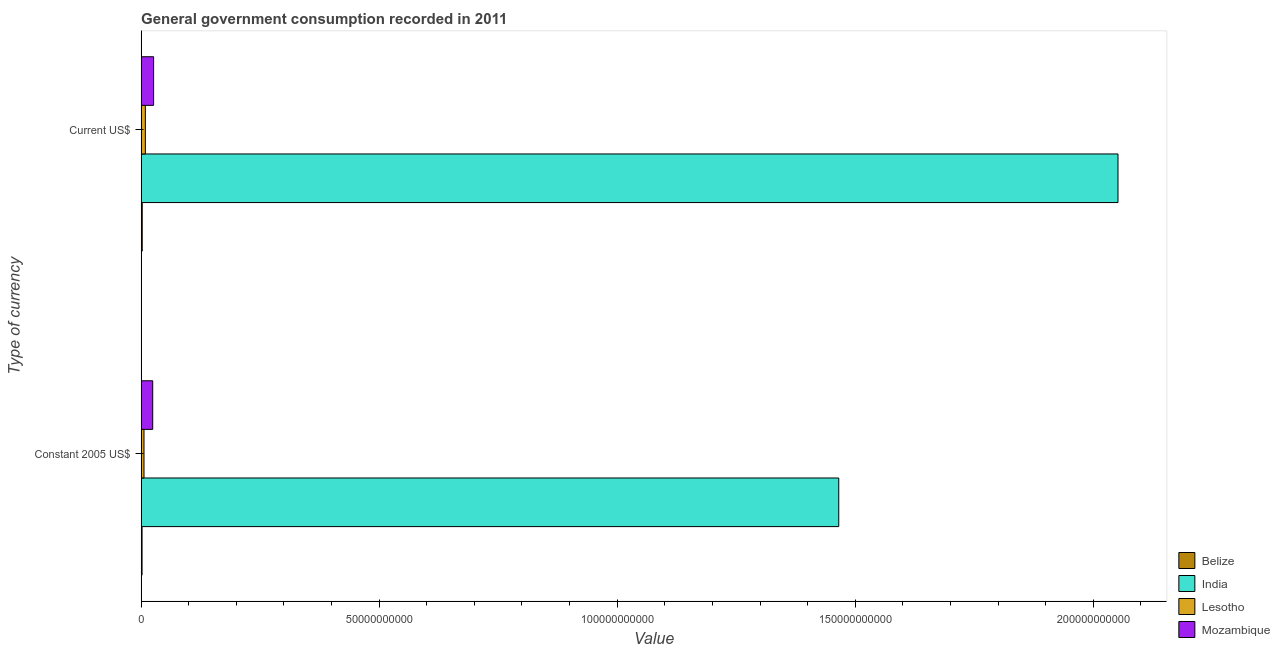How many groups of bars are there?
Provide a short and direct response. 2. Are the number of bars on each tick of the Y-axis equal?
Keep it short and to the point. Yes. How many bars are there on the 1st tick from the top?
Give a very brief answer. 4. How many bars are there on the 2nd tick from the bottom?
Provide a short and direct response. 4. What is the label of the 2nd group of bars from the top?
Your answer should be very brief. Constant 2005 US$. What is the value consumed in constant 2005 us$ in Mozambique?
Provide a short and direct response. 2.43e+09. Across all countries, what is the maximum value consumed in constant 2005 us$?
Ensure brevity in your answer.  1.47e+11. Across all countries, what is the minimum value consumed in current us$?
Offer a terse response. 2.29e+08. In which country was the value consumed in constant 2005 us$ maximum?
Provide a succinct answer. India. In which country was the value consumed in constant 2005 us$ minimum?
Provide a succinct answer. Belize. What is the total value consumed in constant 2005 us$ in the graph?
Your response must be concise. 1.50e+11. What is the difference between the value consumed in constant 2005 us$ in Belize and that in Lesotho?
Make the answer very short. -4.08e+08. What is the difference between the value consumed in constant 2005 us$ in Lesotho and the value consumed in current us$ in India?
Your answer should be compact. -2.05e+11. What is the average value consumed in current us$ per country?
Provide a succinct answer. 5.22e+1. What is the difference between the value consumed in current us$ and value consumed in constant 2005 us$ in Lesotho?
Your answer should be very brief. 2.84e+08. In how many countries, is the value consumed in constant 2005 us$ greater than 190000000000 ?
Provide a succinct answer. 0. What is the ratio of the value consumed in current us$ in India to that in Belize?
Your answer should be very brief. 894.6. Is the value consumed in current us$ in Belize less than that in India?
Keep it short and to the point. Yes. What does the 2nd bar from the top in Current US$ represents?
Offer a very short reply. Lesotho. What does the 2nd bar from the bottom in Current US$ represents?
Offer a terse response. India. How many bars are there?
Make the answer very short. 8. Are the values on the major ticks of X-axis written in scientific E-notation?
Make the answer very short. No. Where does the legend appear in the graph?
Ensure brevity in your answer.  Bottom right. What is the title of the graph?
Provide a short and direct response. General government consumption recorded in 2011. What is the label or title of the X-axis?
Provide a succinct answer. Value. What is the label or title of the Y-axis?
Provide a succinct answer. Type of currency. What is the Value of Belize in Constant 2005 US$?
Your answer should be very brief. 1.93e+08. What is the Value of India in Constant 2005 US$?
Your answer should be very brief. 1.47e+11. What is the Value of Lesotho in Constant 2005 US$?
Offer a very short reply. 6.00e+08. What is the Value of Mozambique in Constant 2005 US$?
Offer a terse response. 2.43e+09. What is the Value of Belize in Current US$?
Your response must be concise. 2.29e+08. What is the Value in India in Current US$?
Your response must be concise. 2.05e+11. What is the Value in Lesotho in Current US$?
Give a very brief answer. 8.84e+08. What is the Value of Mozambique in Current US$?
Provide a succinct answer. 2.62e+09. Across all Type of currency, what is the maximum Value of Belize?
Make the answer very short. 2.29e+08. Across all Type of currency, what is the maximum Value in India?
Offer a terse response. 2.05e+11. Across all Type of currency, what is the maximum Value in Lesotho?
Your answer should be compact. 8.84e+08. Across all Type of currency, what is the maximum Value in Mozambique?
Your response must be concise. 2.62e+09. Across all Type of currency, what is the minimum Value in Belize?
Offer a terse response. 1.93e+08. Across all Type of currency, what is the minimum Value in India?
Provide a succinct answer. 1.47e+11. Across all Type of currency, what is the minimum Value of Lesotho?
Offer a very short reply. 6.00e+08. Across all Type of currency, what is the minimum Value of Mozambique?
Keep it short and to the point. 2.43e+09. What is the total Value of Belize in the graph?
Your response must be concise. 4.22e+08. What is the total Value of India in the graph?
Provide a short and direct response. 3.52e+11. What is the total Value in Lesotho in the graph?
Provide a succinct answer. 1.48e+09. What is the total Value of Mozambique in the graph?
Ensure brevity in your answer.  5.05e+09. What is the difference between the Value of Belize in Constant 2005 US$ and that in Current US$?
Offer a terse response. -3.65e+07. What is the difference between the Value of India in Constant 2005 US$ and that in Current US$?
Your answer should be very brief. -5.87e+1. What is the difference between the Value of Lesotho in Constant 2005 US$ and that in Current US$?
Your response must be concise. -2.84e+08. What is the difference between the Value of Mozambique in Constant 2005 US$ and that in Current US$?
Ensure brevity in your answer.  -1.88e+08. What is the difference between the Value in Belize in Constant 2005 US$ and the Value in India in Current US$?
Make the answer very short. -2.05e+11. What is the difference between the Value of Belize in Constant 2005 US$ and the Value of Lesotho in Current US$?
Provide a short and direct response. -6.91e+08. What is the difference between the Value of Belize in Constant 2005 US$ and the Value of Mozambique in Current US$?
Provide a short and direct response. -2.43e+09. What is the difference between the Value in India in Constant 2005 US$ and the Value in Lesotho in Current US$?
Provide a succinct answer. 1.46e+11. What is the difference between the Value in India in Constant 2005 US$ and the Value in Mozambique in Current US$?
Keep it short and to the point. 1.44e+11. What is the difference between the Value of Lesotho in Constant 2005 US$ and the Value of Mozambique in Current US$?
Your answer should be very brief. -2.02e+09. What is the average Value in Belize per Type of currency?
Keep it short and to the point. 2.11e+08. What is the average Value in India per Type of currency?
Keep it short and to the point. 1.76e+11. What is the average Value in Lesotho per Type of currency?
Provide a short and direct response. 7.42e+08. What is the average Value of Mozambique per Type of currency?
Give a very brief answer. 2.53e+09. What is the difference between the Value of Belize and Value of India in Constant 2005 US$?
Your answer should be very brief. -1.46e+11. What is the difference between the Value of Belize and Value of Lesotho in Constant 2005 US$?
Your answer should be compact. -4.08e+08. What is the difference between the Value of Belize and Value of Mozambique in Constant 2005 US$?
Make the answer very short. -2.24e+09. What is the difference between the Value in India and Value in Lesotho in Constant 2005 US$?
Make the answer very short. 1.46e+11. What is the difference between the Value in India and Value in Mozambique in Constant 2005 US$?
Offer a terse response. 1.44e+11. What is the difference between the Value in Lesotho and Value in Mozambique in Constant 2005 US$?
Your answer should be very brief. -1.83e+09. What is the difference between the Value of Belize and Value of India in Current US$?
Your answer should be very brief. -2.05e+11. What is the difference between the Value in Belize and Value in Lesotho in Current US$?
Offer a very short reply. -6.55e+08. What is the difference between the Value of Belize and Value of Mozambique in Current US$?
Offer a terse response. -2.39e+09. What is the difference between the Value in India and Value in Lesotho in Current US$?
Offer a very short reply. 2.04e+11. What is the difference between the Value of India and Value of Mozambique in Current US$?
Ensure brevity in your answer.  2.03e+11. What is the difference between the Value of Lesotho and Value of Mozambique in Current US$?
Keep it short and to the point. -1.74e+09. What is the ratio of the Value in Belize in Constant 2005 US$ to that in Current US$?
Keep it short and to the point. 0.84. What is the ratio of the Value of India in Constant 2005 US$ to that in Current US$?
Offer a very short reply. 0.71. What is the ratio of the Value in Lesotho in Constant 2005 US$ to that in Current US$?
Offer a terse response. 0.68. What is the ratio of the Value in Mozambique in Constant 2005 US$ to that in Current US$?
Your response must be concise. 0.93. What is the difference between the highest and the second highest Value in Belize?
Offer a very short reply. 3.65e+07. What is the difference between the highest and the second highest Value of India?
Ensure brevity in your answer.  5.87e+1. What is the difference between the highest and the second highest Value of Lesotho?
Give a very brief answer. 2.84e+08. What is the difference between the highest and the second highest Value of Mozambique?
Offer a terse response. 1.88e+08. What is the difference between the highest and the lowest Value of Belize?
Your answer should be very brief. 3.65e+07. What is the difference between the highest and the lowest Value in India?
Your response must be concise. 5.87e+1. What is the difference between the highest and the lowest Value in Lesotho?
Provide a succinct answer. 2.84e+08. What is the difference between the highest and the lowest Value in Mozambique?
Ensure brevity in your answer.  1.88e+08. 